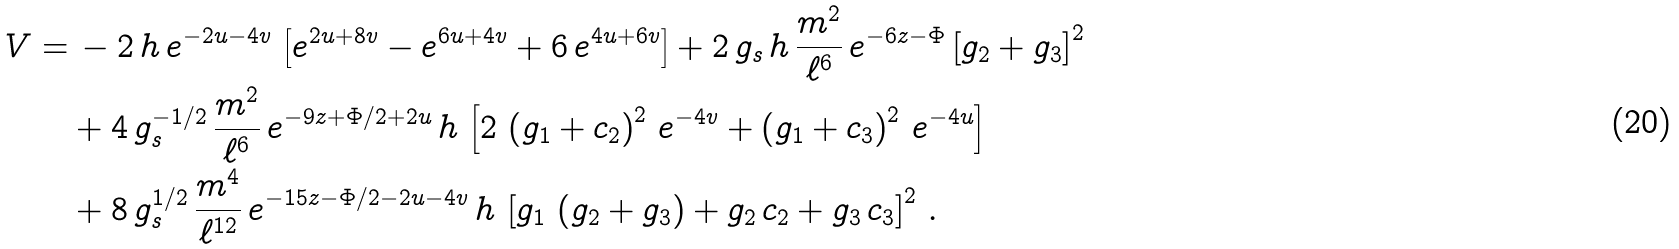Convert formula to latex. <formula><loc_0><loc_0><loc_500><loc_500>V = & \, - 2 \, h \, e ^ { - 2 u - 4 v } \, \left [ e ^ { 2 u + 8 v } - e ^ { 6 u + 4 v } + 6 \, e ^ { 4 u + 6 v } \right ] + 2 \, g _ { s } \, h \, \frac { m ^ { 2 } } { \ell ^ { 6 } } \, e ^ { - 6 z - \Phi } \left [ g _ { 2 } + g _ { 3 } \right ] ^ { 2 } \\ & + 4 \, g _ { s } ^ { - 1 / 2 } \, \frac { m ^ { 2 } } { \ell ^ { 6 } } \, e ^ { - 9 z + \Phi / 2 + 2 u } \, h \, \left [ 2 \, \left ( g _ { 1 } + c _ { 2 } \right ) ^ { 2 } \, e ^ { - 4 v } + \left ( g _ { 1 } + c _ { 3 } \right ) ^ { 2 } \, e ^ { - 4 u } \right ] \\ & + 8 \, g _ { s } ^ { 1 / 2 } \, \frac { m ^ { 4 } } { \ell ^ { 1 2 } } \, e ^ { - 1 5 z - \Phi / 2 - 2 u - 4 v } \, h \, \left [ g _ { 1 } \, \left ( g _ { 2 } + g _ { 3 } \right ) + g _ { 2 } \, c _ { 2 } + g _ { 3 } \, c _ { 3 } \right ] ^ { 2 } \, .</formula> 